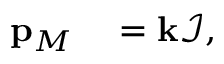Convert formula to latex. <formula><loc_0><loc_0><loc_500><loc_500>\begin{array} { r l } { p _ { M } } & = k \mathcal { I } , } \end{array}</formula> 